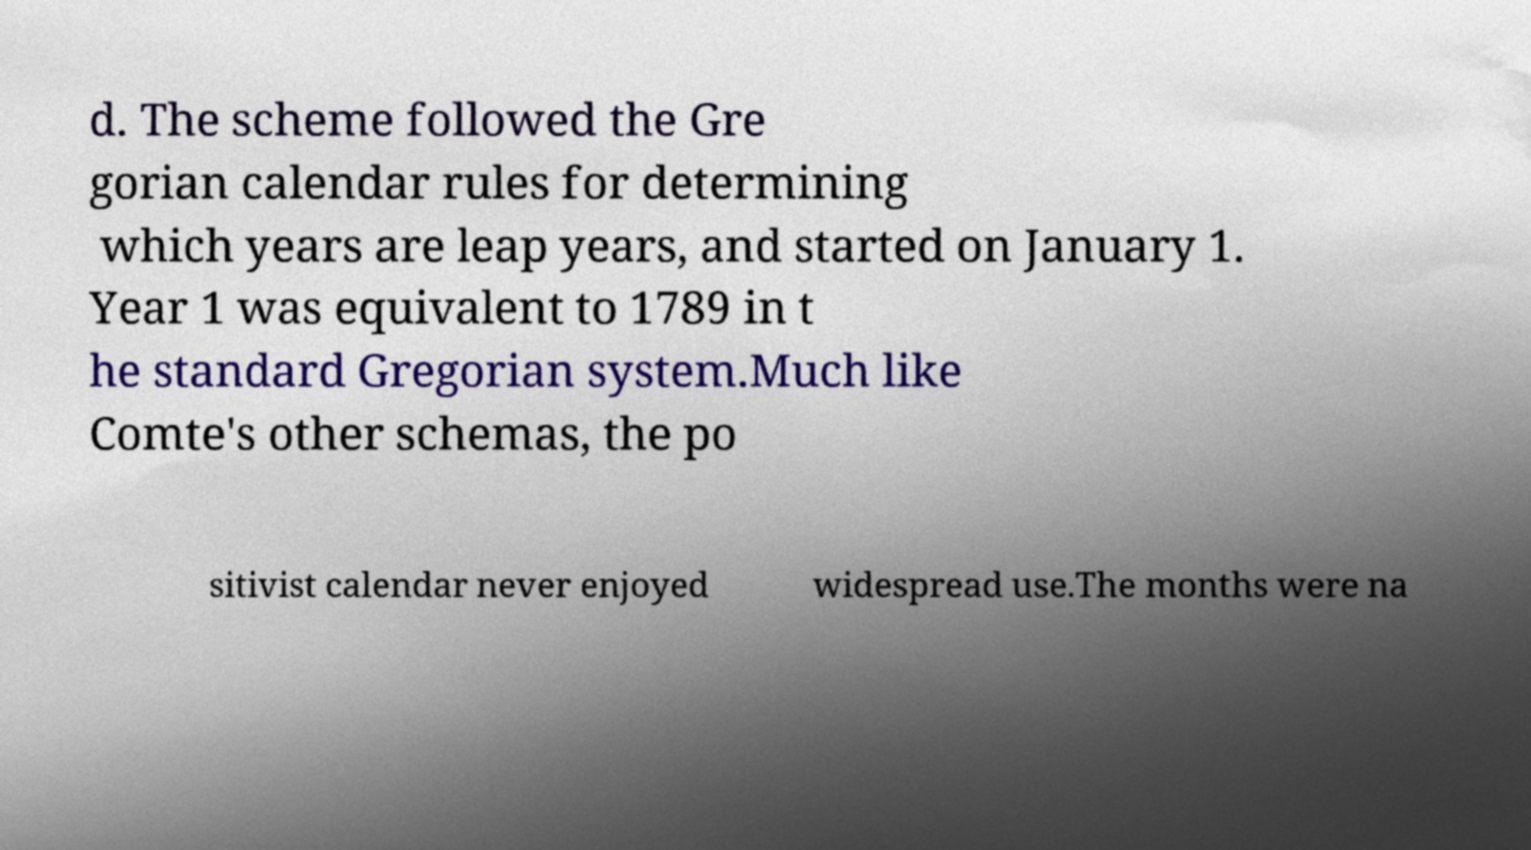Can you accurately transcribe the text from the provided image for me? d. The scheme followed the Gre gorian calendar rules for determining which years are leap years, and started on January 1. Year 1 was equivalent to 1789 in t he standard Gregorian system.Much like Comte's other schemas, the po sitivist calendar never enjoyed widespread use.The months were na 